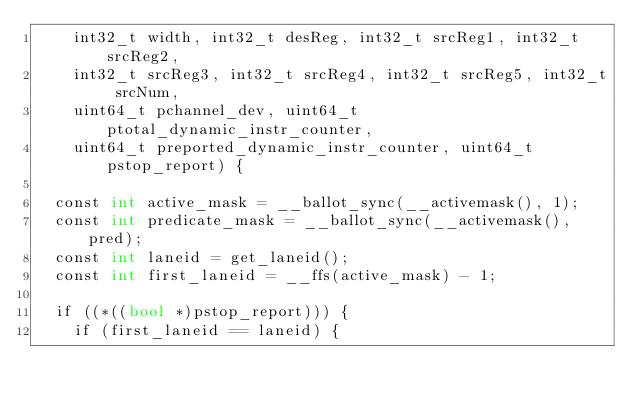<code> <loc_0><loc_0><loc_500><loc_500><_Cuda_>    int32_t width, int32_t desReg, int32_t srcReg1, int32_t srcReg2,
    int32_t srcReg3, int32_t srcReg4, int32_t srcReg5, int32_t srcNum,
    uint64_t pchannel_dev, uint64_t ptotal_dynamic_instr_counter,
    uint64_t preported_dynamic_instr_counter, uint64_t pstop_report) {

  const int active_mask = __ballot_sync(__activemask(), 1);
  const int predicate_mask = __ballot_sync(__activemask(), pred);
  const int laneid = get_laneid();
  const int first_laneid = __ffs(active_mask) - 1;

  if ((*((bool *)pstop_report))) {
    if (first_laneid == laneid) {</code> 